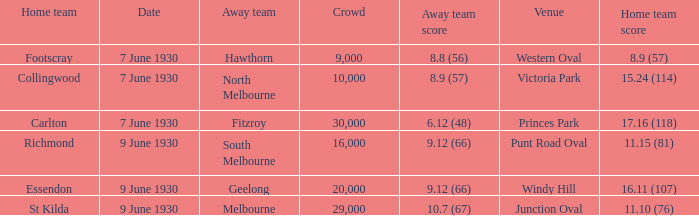What is the mean attendance for hawthorn matches as the away team? 9000.0. Can you give me this table as a dict? {'header': ['Home team', 'Date', 'Away team', 'Crowd', 'Away team score', 'Venue', 'Home team score'], 'rows': [['Footscray', '7 June 1930', 'Hawthorn', '9,000', '8.8 (56)', 'Western Oval', '8.9 (57)'], ['Collingwood', '7 June 1930', 'North Melbourne', '10,000', '8.9 (57)', 'Victoria Park', '15.24 (114)'], ['Carlton', '7 June 1930', 'Fitzroy', '30,000', '6.12 (48)', 'Princes Park', '17.16 (118)'], ['Richmond', '9 June 1930', 'South Melbourne', '16,000', '9.12 (66)', 'Punt Road Oval', '11.15 (81)'], ['Essendon', '9 June 1930', 'Geelong', '20,000', '9.12 (66)', 'Windy Hill', '16.11 (107)'], ['St Kilda', '9 June 1930', 'Melbourne', '29,000', '10.7 (67)', 'Junction Oval', '11.10 (76)']]} 